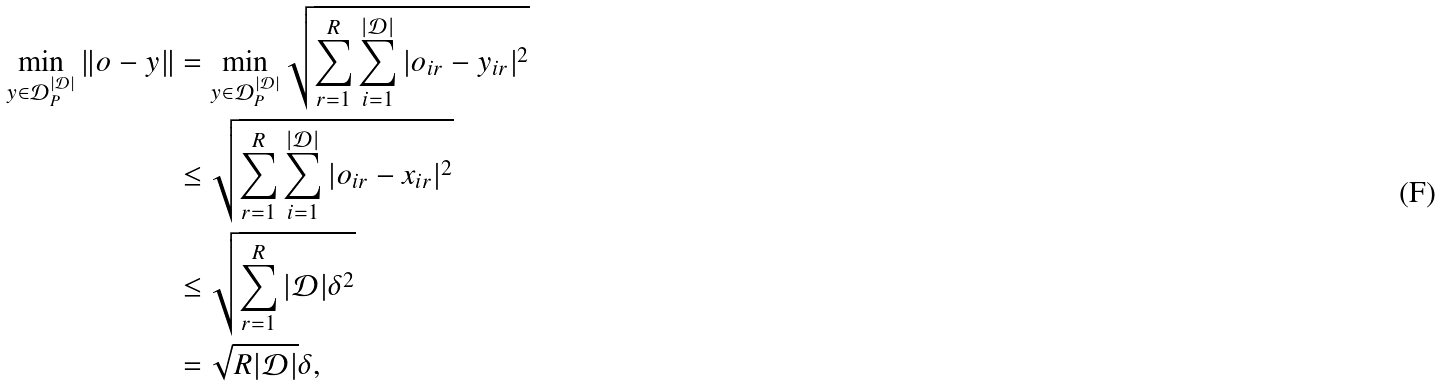<formula> <loc_0><loc_0><loc_500><loc_500>\min _ { y \in \mathcal { D } _ { P } ^ { | \mathcal { D } | } } \| o - y \| & = \min _ { y \in \mathcal { D } _ { P } ^ { | \mathcal { D } | } } \sqrt { \sum _ { r = 1 } ^ { R } \sum _ { i = 1 } ^ { | \mathcal { D } | } | o _ { i r } - y _ { i r } | ^ { 2 } } \\ & \leq \sqrt { \sum _ { r = 1 } ^ { R } \sum _ { i = 1 } ^ { | \mathcal { D } | } | o _ { i r } - x _ { i r } | ^ { 2 } } \\ & \leq \sqrt { \sum _ { r = 1 } ^ { R } | \mathcal { D } | \delta ^ { 2 } } \\ & = \sqrt { R | \mathcal { D } | } \delta ,</formula> 